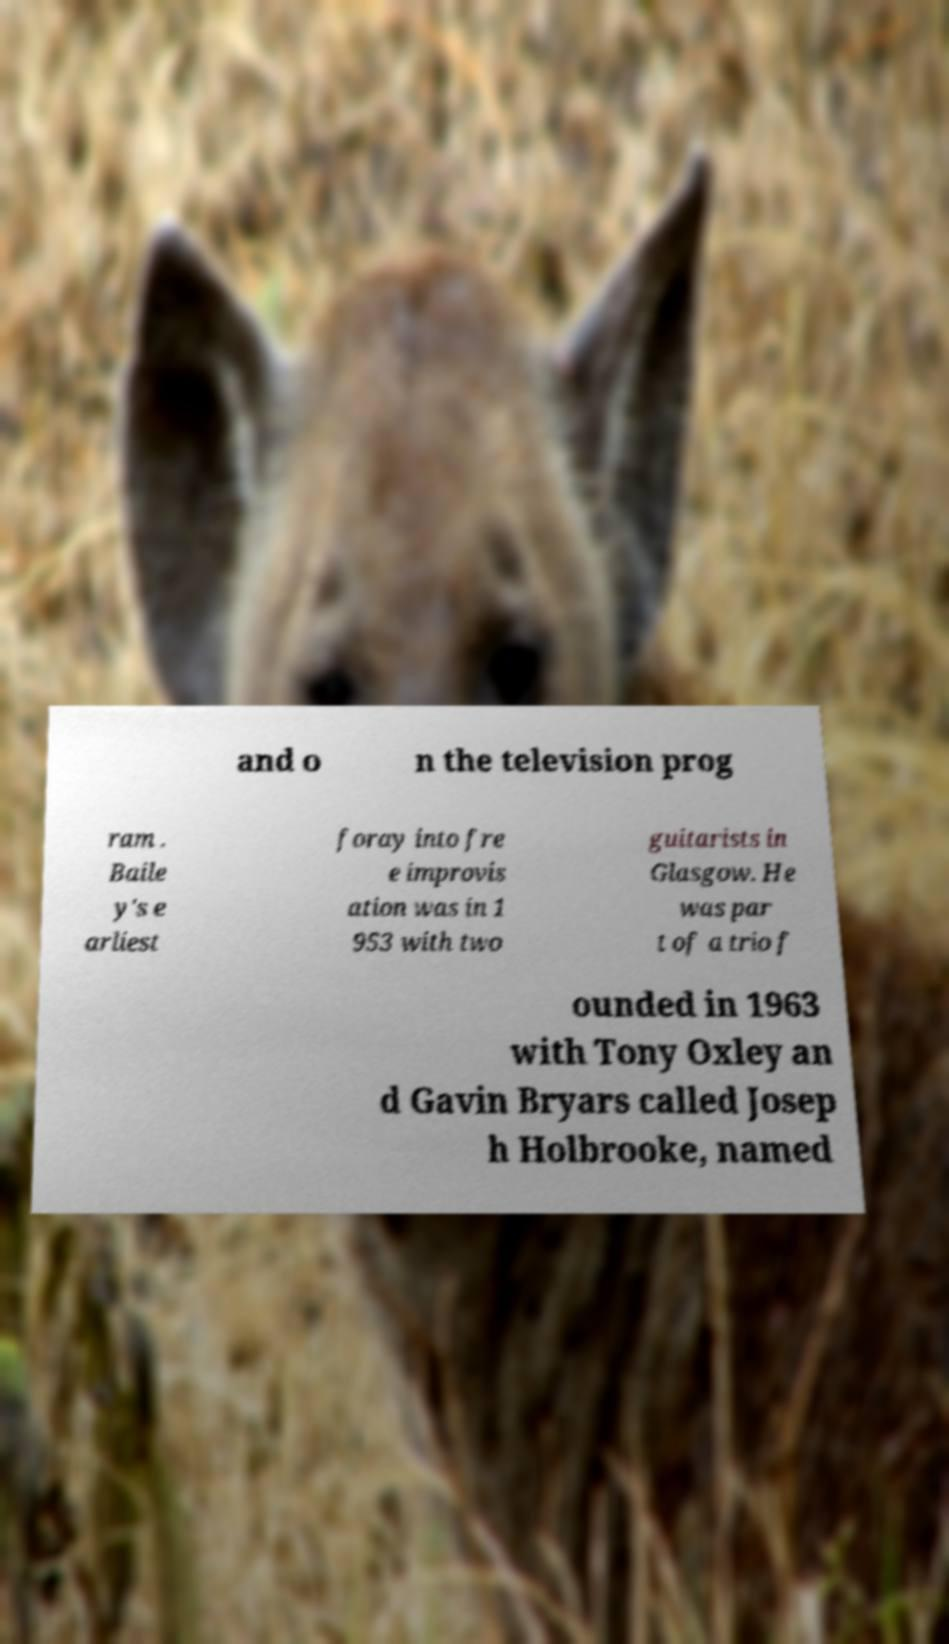Please read and relay the text visible in this image. What does it say? and o n the television prog ram . Baile y's e arliest foray into fre e improvis ation was in 1 953 with two guitarists in Glasgow. He was par t of a trio f ounded in 1963 with Tony Oxley an d Gavin Bryars called Josep h Holbrooke, named 